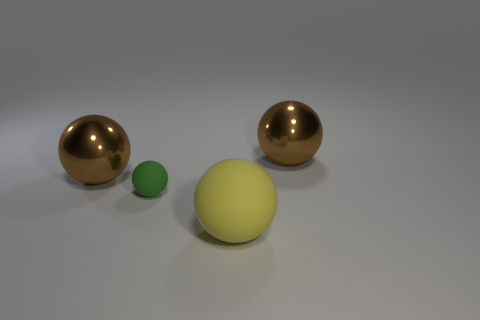Add 2 yellow objects. How many objects exist? 6 Subtract all big balls. How many balls are left? 1 Subtract all gray cylinders. How many brown balls are left? 2 Subtract all brown spheres. How many spheres are left? 2 Add 4 big yellow rubber things. How many big yellow rubber things are left? 5 Add 2 green spheres. How many green spheres exist? 3 Subtract 0 cyan balls. How many objects are left? 4 Subtract all brown balls. Subtract all blue blocks. How many balls are left? 2 Subtract all tiny gray objects. Subtract all yellow rubber things. How many objects are left? 3 